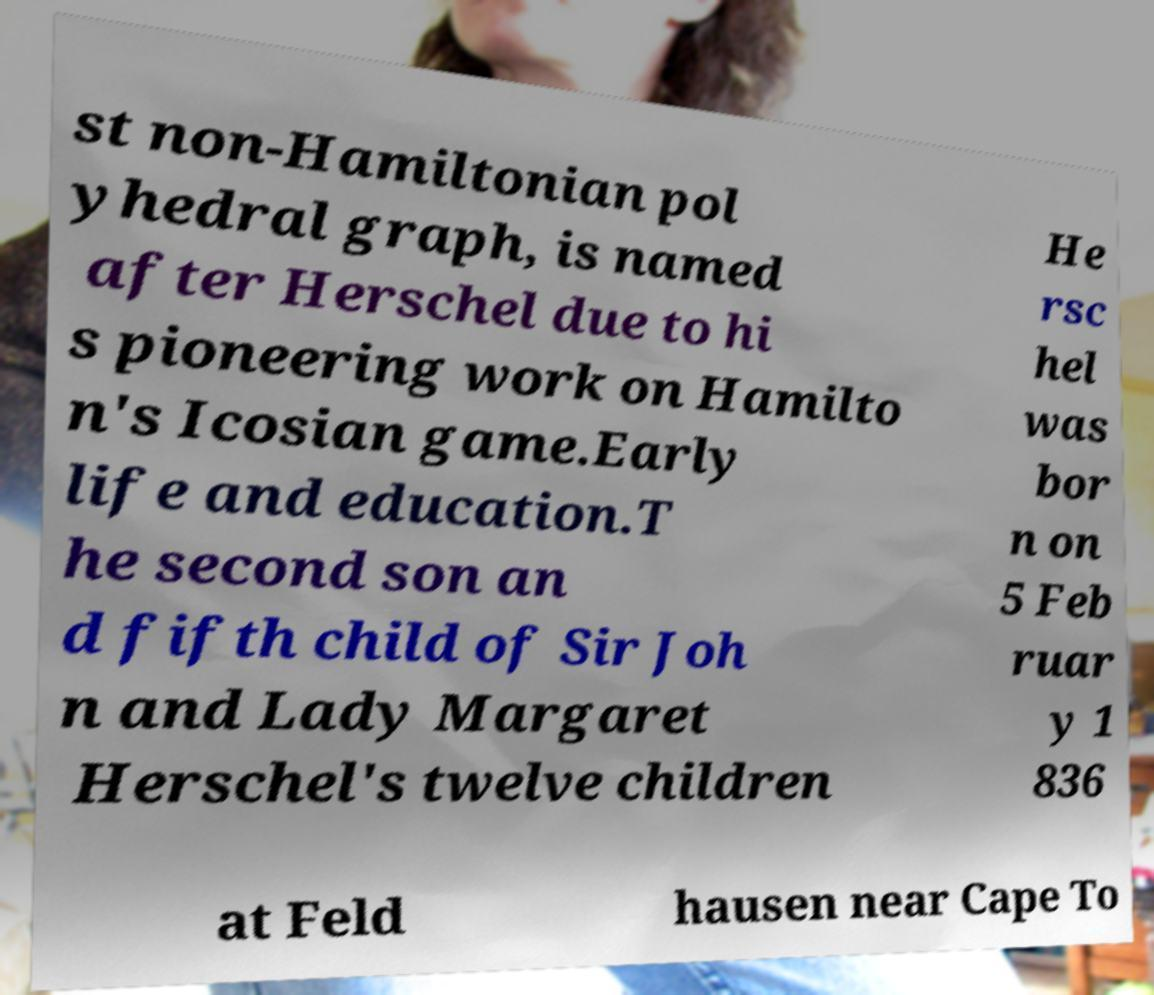Could you extract and type out the text from this image? st non-Hamiltonian pol yhedral graph, is named after Herschel due to hi s pioneering work on Hamilto n's Icosian game.Early life and education.T he second son an d fifth child of Sir Joh n and Lady Margaret Herschel's twelve children He rsc hel was bor n on 5 Feb ruar y 1 836 at Feld hausen near Cape To 